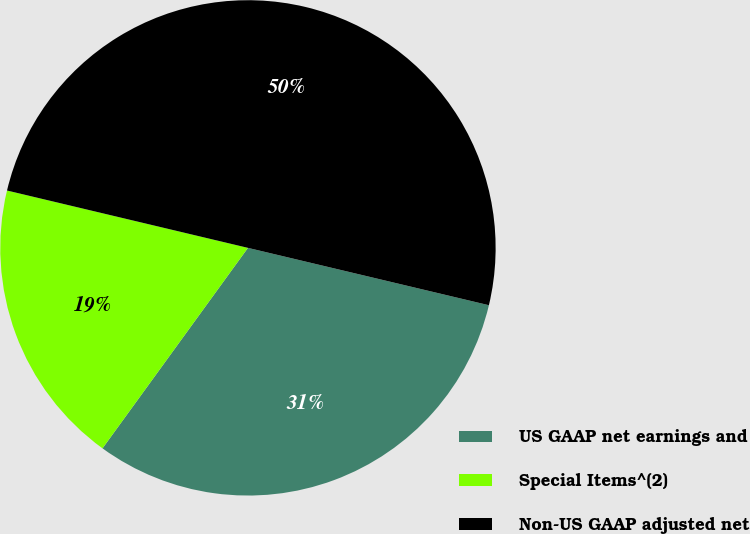Convert chart. <chart><loc_0><loc_0><loc_500><loc_500><pie_chart><fcel>US GAAP net earnings and<fcel>Special Items^(2)<fcel>Non-US GAAP adjusted net<nl><fcel>31.27%<fcel>18.73%<fcel>50.0%<nl></chart> 